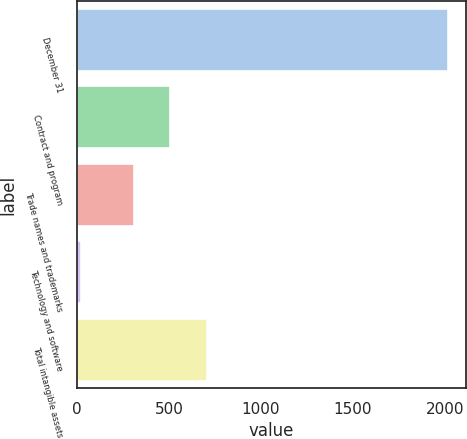<chart> <loc_0><loc_0><loc_500><loc_500><bar_chart><fcel>December 31<fcel>Contract and program<fcel>Trade names and trademarks<fcel>Technology and software<fcel>Total intangible assets<nl><fcel>2016<fcel>506.7<fcel>307<fcel>19<fcel>706.4<nl></chart> 